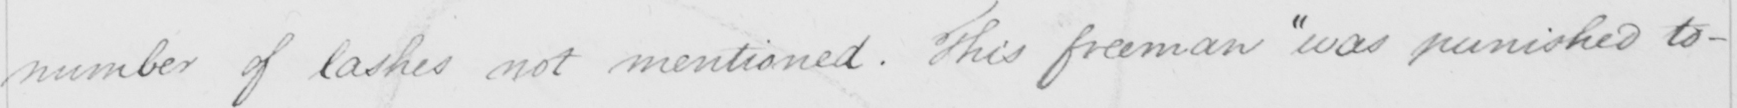Transcribe the text shown in this historical manuscript line. number of lashes not mentioned . This freeman  " was punished to- 